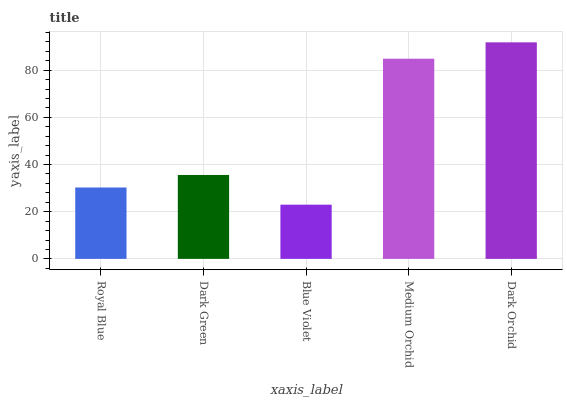Is Blue Violet the minimum?
Answer yes or no. Yes. Is Dark Orchid the maximum?
Answer yes or no. Yes. Is Dark Green the minimum?
Answer yes or no. No. Is Dark Green the maximum?
Answer yes or no. No. Is Dark Green greater than Royal Blue?
Answer yes or no. Yes. Is Royal Blue less than Dark Green?
Answer yes or no. Yes. Is Royal Blue greater than Dark Green?
Answer yes or no. No. Is Dark Green less than Royal Blue?
Answer yes or no. No. Is Dark Green the high median?
Answer yes or no. Yes. Is Dark Green the low median?
Answer yes or no. Yes. Is Dark Orchid the high median?
Answer yes or no. No. Is Medium Orchid the low median?
Answer yes or no. No. 